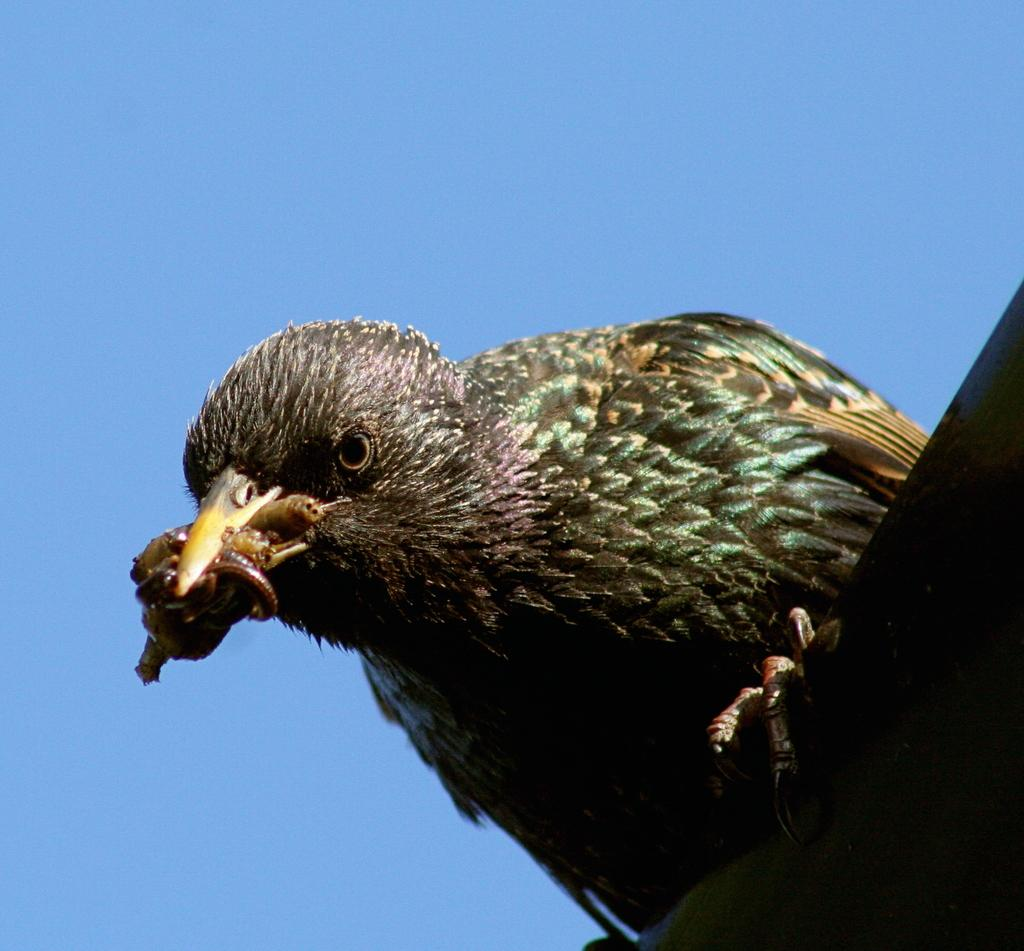What is the main subject of the image? There is a bird in the center of the image. What is the bird doing in the image? The bird is holding something with its beak and sitting on an object. What can be seen in the background of the image? The background of the image is the sky. What type of wool is the bird using to pay off its debt in the image? There is no wool or debt mentioned in the image; it features a bird holding something with its beak and sitting on an object against a sky background. How many chickens are present in the image? There are no chickens present in the image; it features a bird holding something with its beak and sitting on an object against a sky background. 